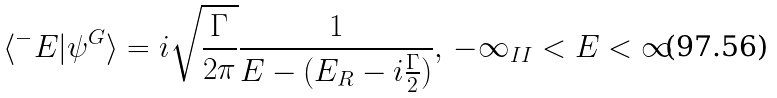<formula> <loc_0><loc_0><loc_500><loc_500>\langle ^ { - } E | \psi ^ { G } \rangle = i \sqrt { \frac { \Gamma } { 2 \pi } } \frac { 1 } { E - ( E _ { R } - i \frac { \Gamma } { 2 } ) } , \, - \infty _ { I I } < E < \infty</formula> 